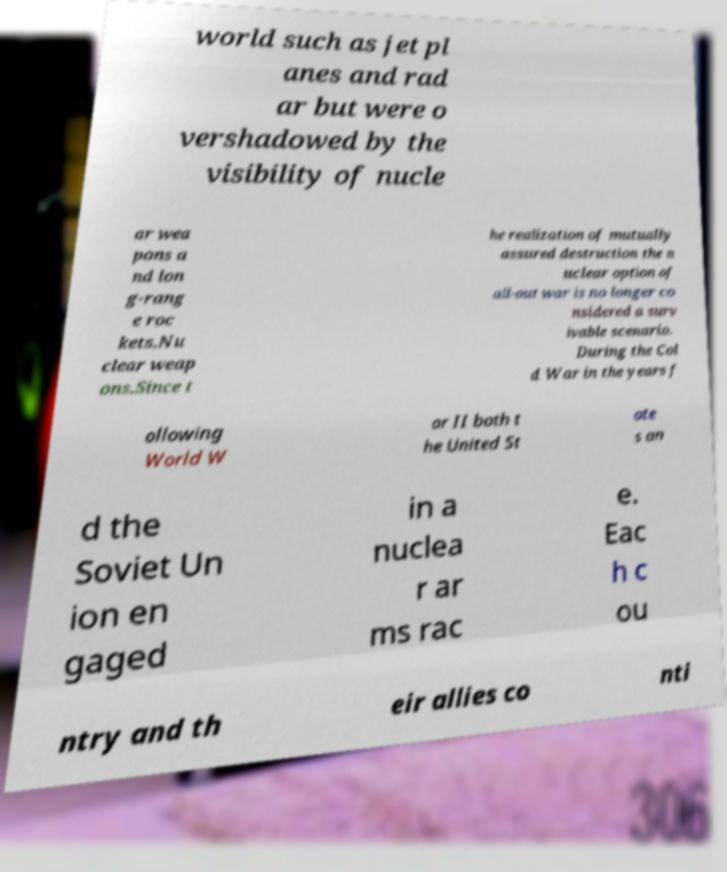Could you extract and type out the text from this image? world such as jet pl anes and rad ar but were o vershadowed by the visibility of nucle ar wea pons a nd lon g-rang e roc kets.Nu clear weap ons.Since t he realization of mutually assured destruction the n uclear option of all-out war is no longer co nsidered a surv ivable scenario. During the Col d War in the years f ollowing World W ar II both t he United St ate s an d the Soviet Un ion en gaged in a nuclea r ar ms rac e. Eac h c ou ntry and th eir allies co nti 